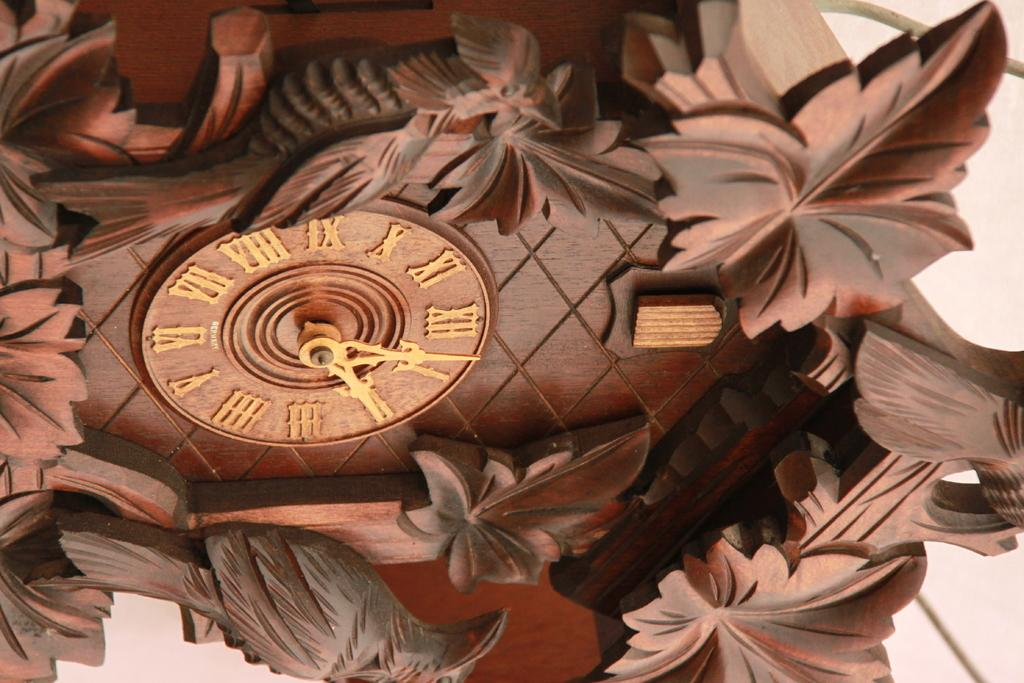<image>
Write a terse but informative summary of the picture. The time on a cuckoo clock is almost five after three. 